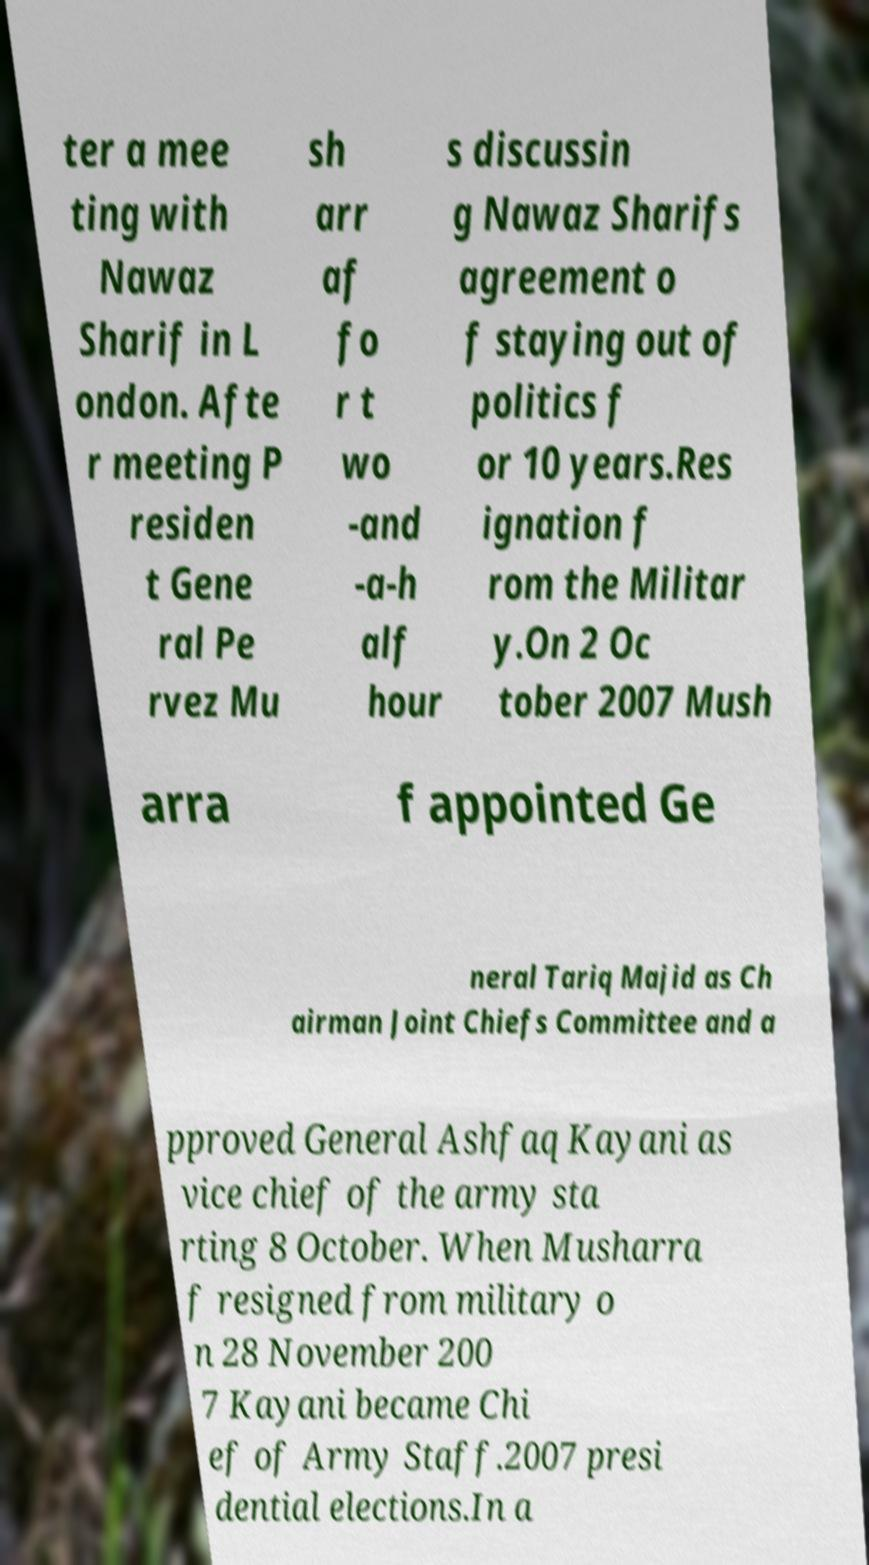Could you extract and type out the text from this image? ter a mee ting with Nawaz Sharif in L ondon. Afte r meeting P residen t Gene ral Pe rvez Mu sh arr af fo r t wo -and -a-h alf hour s discussin g Nawaz Sharifs agreement o f staying out of politics f or 10 years.Res ignation f rom the Militar y.On 2 Oc tober 2007 Mush arra f appointed Ge neral Tariq Majid as Ch airman Joint Chiefs Committee and a pproved General Ashfaq Kayani as vice chief of the army sta rting 8 October. When Musharra f resigned from military o n 28 November 200 7 Kayani became Chi ef of Army Staff.2007 presi dential elections.In a 